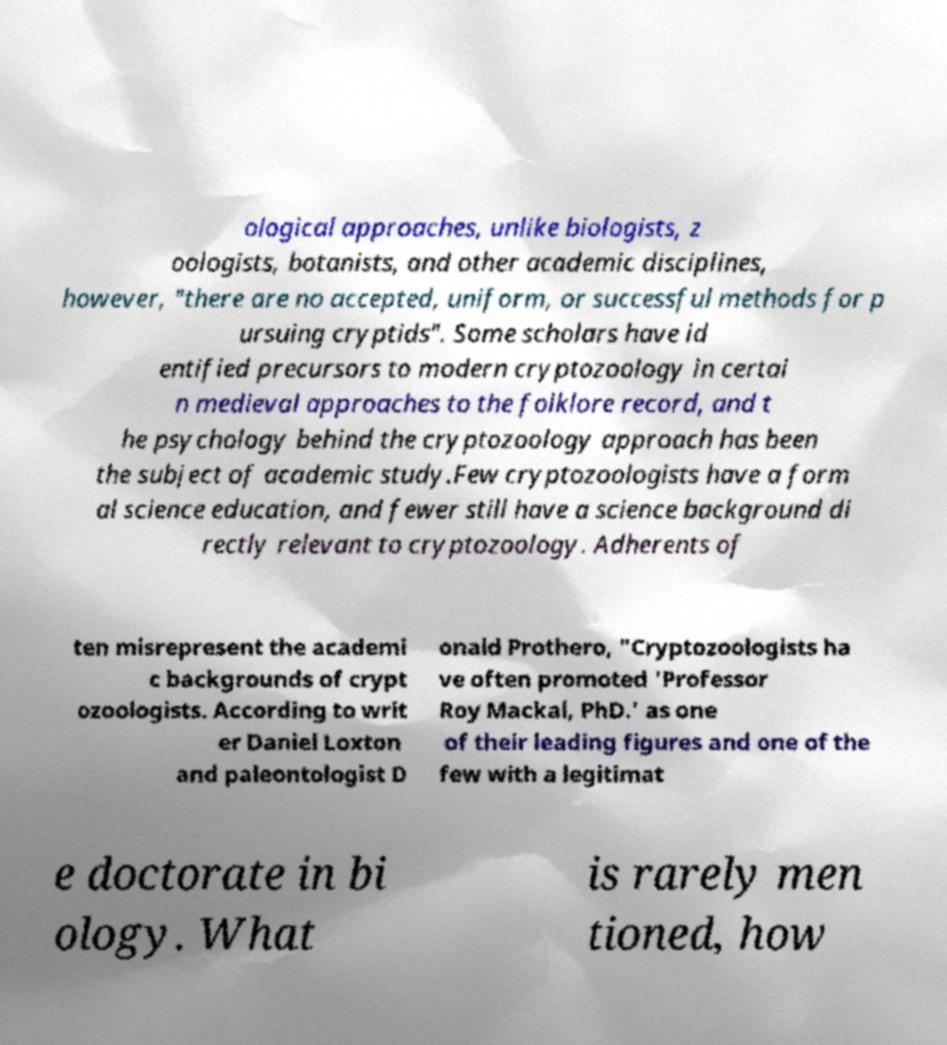Could you assist in decoding the text presented in this image and type it out clearly? ological approaches, unlike biologists, z oologists, botanists, and other academic disciplines, however, "there are no accepted, uniform, or successful methods for p ursuing cryptids". Some scholars have id entified precursors to modern cryptozoology in certai n medieval approaches to the folklore record, and t he psychology behind the cryptozoology approach has been the subject of academic study.Few cryptozoologists have a form al science education, and fewer still have a science background di rectly relevant to cryptozoology. Adherents of ten misrepresent the academi c backgrounds of crypt ozoologists. According to writ er Daniel Loxton and paleontologist D onald Prothero, "Cryptozoologists ha ve often promoted 'Professor Roy Mackal, PhD.' as one of their leading figures and one of the few with a legitimat e doctorate in bi ology. What is rarely men tioned, how 